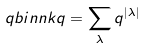Convert formula to latex. <formula><loc_0><loc_0><loc_500><loc_500>\ q b i n { n } { k } { q } = \sum _ { \lambda } q ^ { | \lambda | }</formula> 